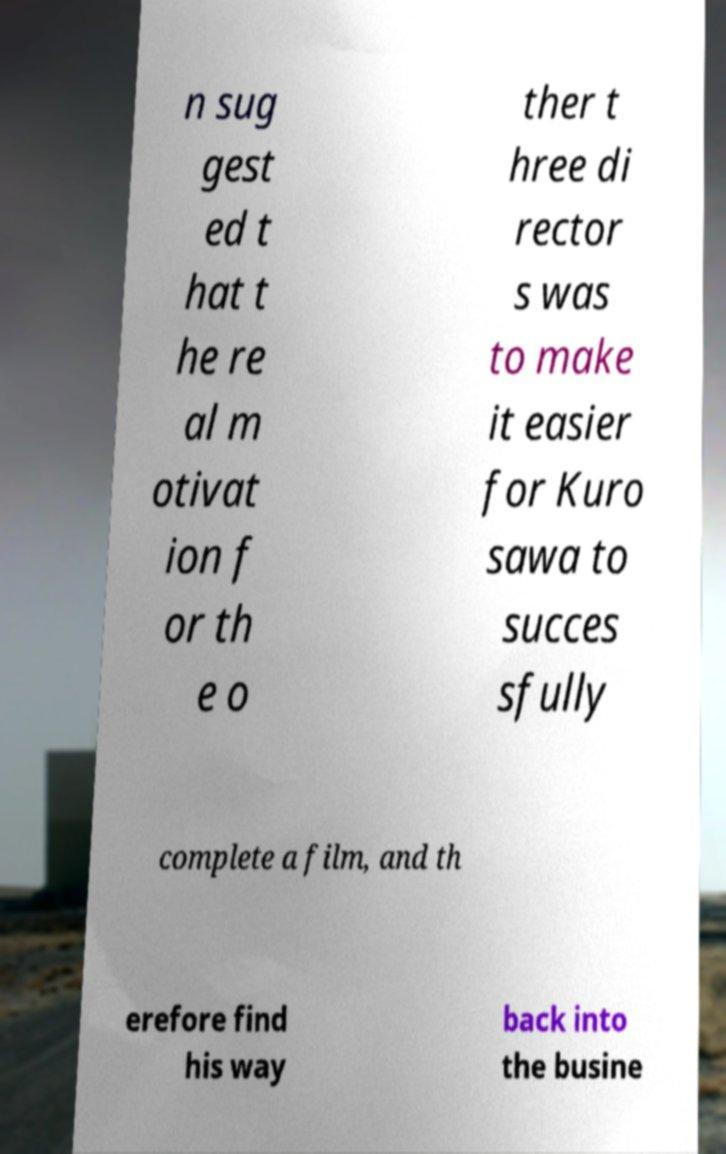For documentation purposes, I need the text within this image transcribed. Could you provide that? n sug gest ed t hat t he re al m otivat ion f or th e o ther t hree di rector s was to make it easier for Kuro sawa to succes sfully complete a film, and th erefore find his way back into the busine 